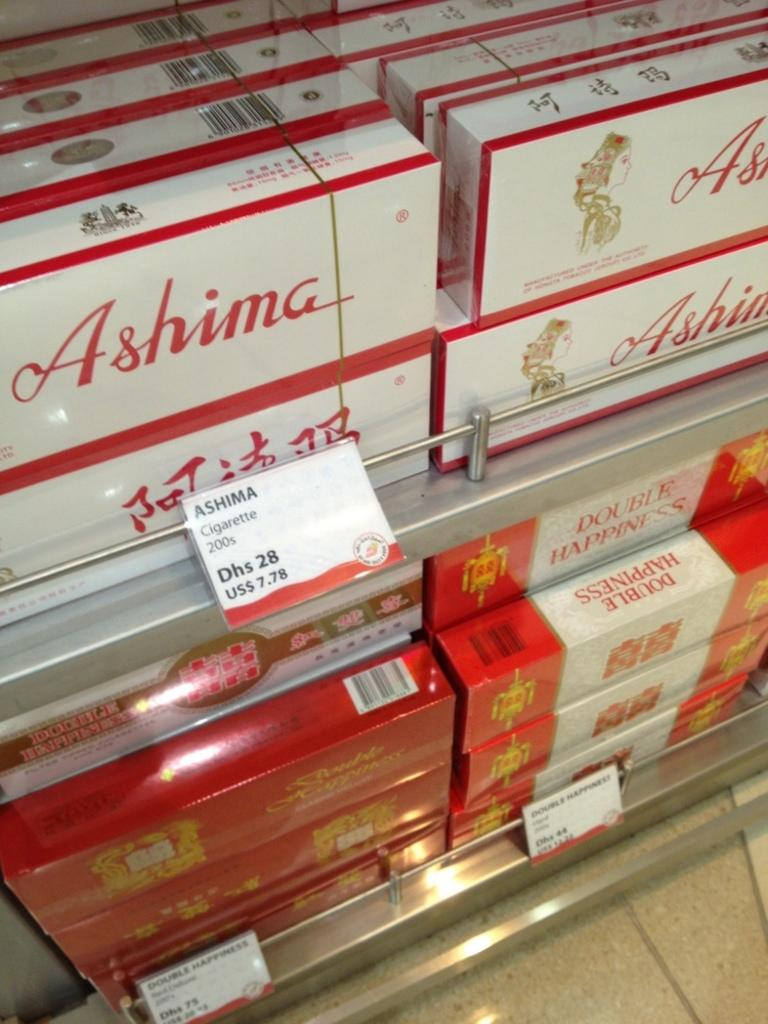Provide a one-sentence caption for the provided image. Boxes of Ashima cigarettes are shelved and sticker-priced at $7.78. 